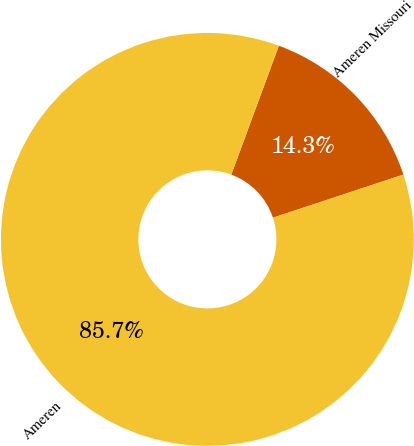Convert chart. <chart><loc_0><loc_0><loc_500><loc_500><pie_chart><fcel>Ameren Missouri<fcel>Ameren<nl><fcel>14.29%<fcel>85.71%<nl></chart> 